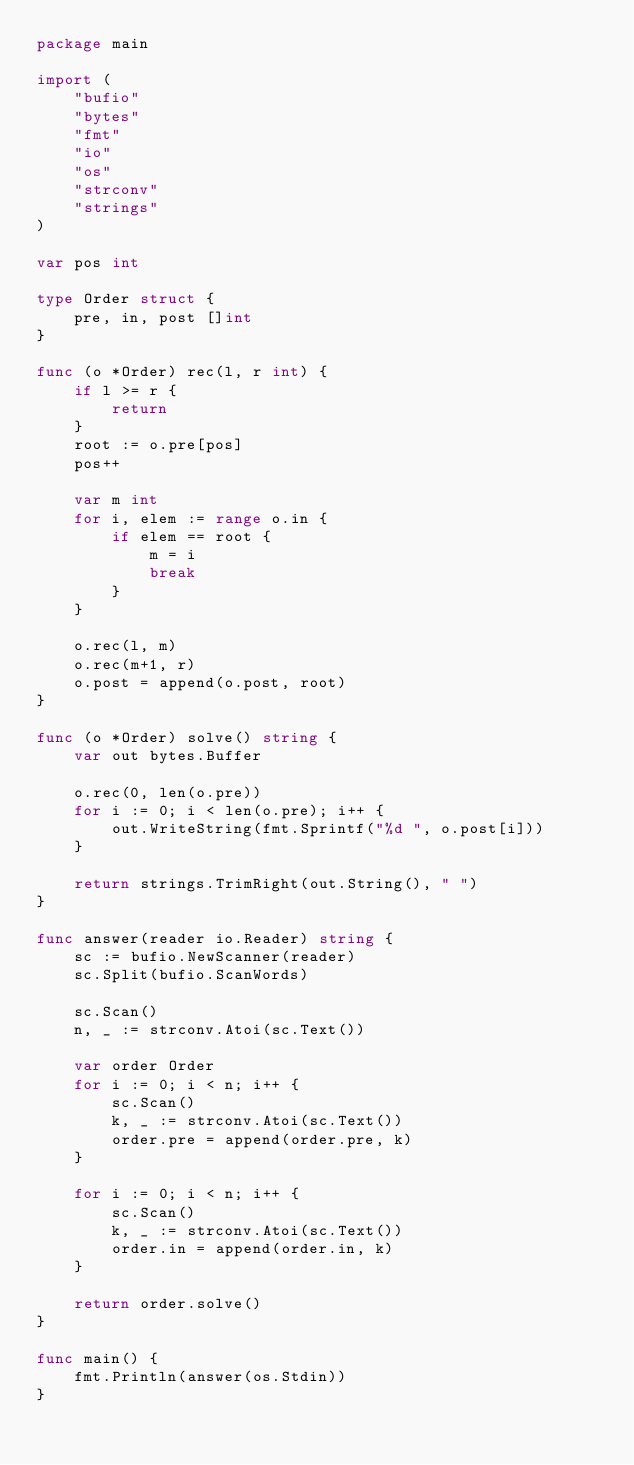Convert code to text. <code><loc_0><loc_0><loc_500><loc_500><_Go_>package main

import (
	"bufio"
	"bytes"
	"fmt"
	"io"
	"os"
	"strconv"
	"strings"
)

var pos int

type Order struct {
	pre, in, post []int
}

func (o *Order) rec(l, r int) {
	if l >= r {
		return
	}
	root := o.pre[pos]
	pos++

	var m int
	for i, elem := range o.in {
		if elem == root {
			m = i
			break
		}
	}

	o.rec(l, m)
	o.rec(m+1, r)
	o.post = append(o.post, root)
}

func (o *Order) solve() string {
	var out bytes.Buffer

	o.rec(0, len(o.pre))
	for i := 0; i < len(o.pre); i++ {
		out.WriteString(fmt.Sprintf("%d ", o.post[i]))
	}

	return strings.TrimRight(out.String(), " ")
}

func answer(reader io.Reader) string {
	sc := bufio.NewScanner(reader)
	sc.Split(bufio.ScanWords)

	sc.Scan()
	n, _ := strconv.Atoi(sc.Text())

	var order Order
	for i := 0; i < n; i++ {
		sc.Scan()
		k, _ := strconv.Atoi(sc.Text())
		order.pre = append(order.pre, k)
	}

	for i := 0; i < n; i++ {
		sc.Scan()
		k, _ := strconv.Atoi(sc.Text())
		order.in = append(order.in, k)
	}

	return order.solve()
}

func main() {
	fmt.Println(answer(os.Stdin))
}

</code> 